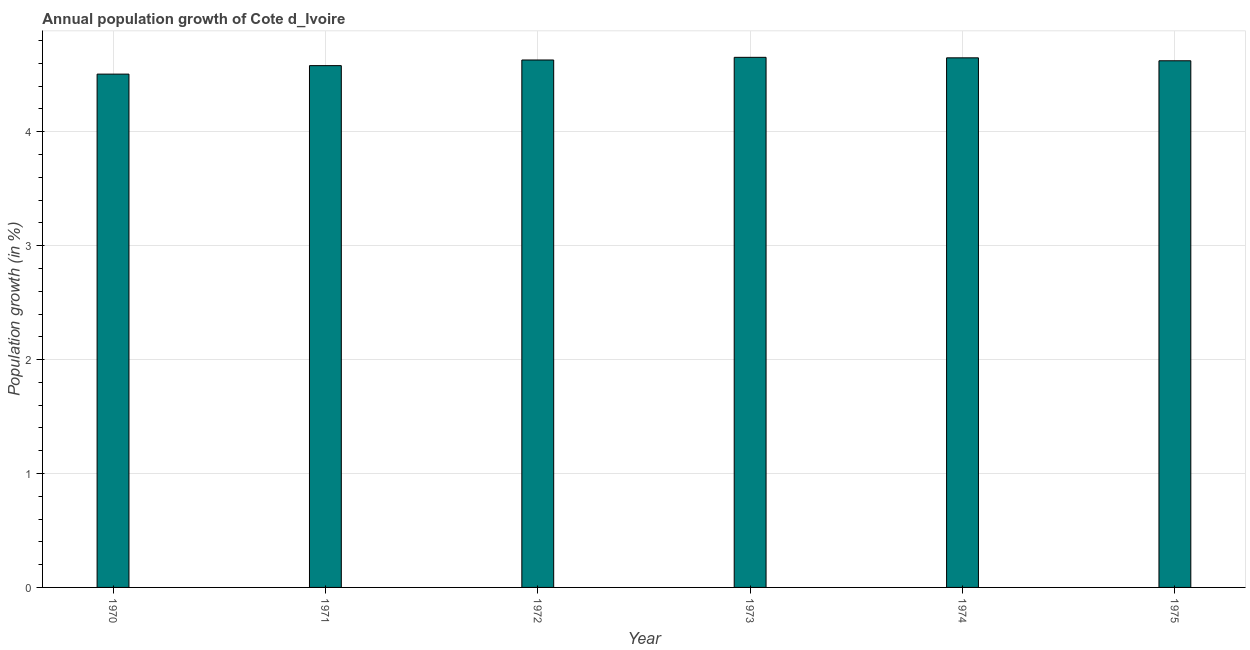Does the graph contain any zero values?
Ensure brevity in your answer.  No. What is the title of the graph?
Your response must be concise. Annual population growth of Cote d_Ivoire. What is the label or title of the X-axis?
Offer a terse response. Year. What is the label or title of the Y-axis?
Your answer should be compact. Population growth (in %). What is the population growth in 1973?
Your response must be concise. 4.65. Across all years, what is the maximum population growth?
Offer a very short reply. 4.65. Across all years, what is the minimum population growth?
Your answer should be very brief. 4.51. In which year was the population growth maximum?
Your answer should be very brief. 1973. What is the sum of the population growth?
Give a very brief answer. 27.64. What is the difference between the population growth in 1972 and 1975?
Your response must be concise. 0.01. What is the average population growth per year?
Make the answer very short. 4.61. What is the median population growth?
Ensure brevity in your answer.  4.63. What is the difference between the highest and the second highest population growth?
Provide a succinct answer. 0. Is the sum of the population growth in 1971 and 1973 greater than the maximum population growth across all years?
Make the answer very short. Yes. What is the difference between the highest and the lowest population growth?
Make the answer very short. 0.15. In how many years, is the population growth greater than the average population growth taken over all years?
Ensure brevity in your answer.  4. How many years are there in the graph?
Provide a short and direct response. 6. What is the difference between two consecutive major ticks on the Y-axis?
Your answer should be compact. 1. Are the values on the major ticks of Y-axis written in scientific E-notation?
Your answer should be compact. No. What is the Population growth (in %) of 1970?
Your answer should be very brief. 4.51. What is the Population growth (in %) in 1971?
Your answer should be very brief. 4.58. What is the Population growth (in %) in 1972?
Offer a very short reply. 4.63. What is the Population growth (in %) in 1973?
Keep it short and to the point. 4.65. What is the Population growth (in %) of 1974?
Offer a very short reply. 4.65. What is the Population growth (in %) in 1975?
Make the answer very short. 4.62. What is the difference between the Population growth (in %) in 1970 and 1971?
Offer a very short reply. -0.07. What is the difference between the Population growth (in %) in 1970 and 1972?
Provide a short and direct response. -0.12. What is the difference between the Population growth (in %) in 1970 and 1973?
Your response must be concise. -0.15. What is the difference between the Population growth (in %) in 1970 and 1974?
Ensure brevity in your answer.  -0.14. What is the difference between the Population growth (in %) in 1970 and 1975?
Make the answer very short. -0.12. What is the difference between the Population growth (in %) in 1971 and 1972?
Ensure brevity in your answer.  -0.05. What is the difference between the Population growth (in %) in 1971 and 1973?
Offer a terse response. -0.07. What is the difference between the Population growth (in %) in 1971 and 1974?
Give a very brief answer. -0.07. What is the difference between the Population growth (in %) in 1971 and 1975?
Provide a short and direct response. -0.04. What is the difference between the Population growth (in %) in 1972 and 1973?
Make the answer very short. -0.02. What is the difference between the Population growth (in %) in 1972 and 1974?
Keep it short and to the point. -0.02. What is the difference between the Population growth (in %) in 1972 and 1975?
Provide a short and direct response. 0.01. What is the difference between the Population growth (in %) in 1973 and 1974?
Provide a succinct answer. 0. What is the difference between the Population growth (in %) in 1973 and 1975?
Provide a short and direct response. 0.03. What is the difference between the Population growth (in %) in 1974 and 1975?
Your answer should be compact. 0.03. What is the ratio of the Population growth (in %) in 1970 to that in 1972?
Your answer should be very brief. 0.97. What is the ratio of the Population growth (in %) in 1970 to that in 1973?
Give a very brief answer. 0.97. What is the ratio of the Population growth (in %) in 1970 to that in 1975?
Provide a short and direct response. 0.97. What is the ratio of the Population growth (in %) in 1971 to that in 1972?
Provide a short and direct response. 0.99. What is the ratio of the Population growth (in %) in 1971 to that in 1973?
Your answer should be very brief. 0.98. What is the ratio of the Population growth (in %) in 1971 to that in 1974?
Your answer should be compact. 0.98. What is the ratio of the Population growth (in %) in 1972 to that in 1973?
Make the answer very short. 0.99. What is the ratio of the Population growth (in %) in 1973 to that in 1974?
Give a very brief answer. 1. 